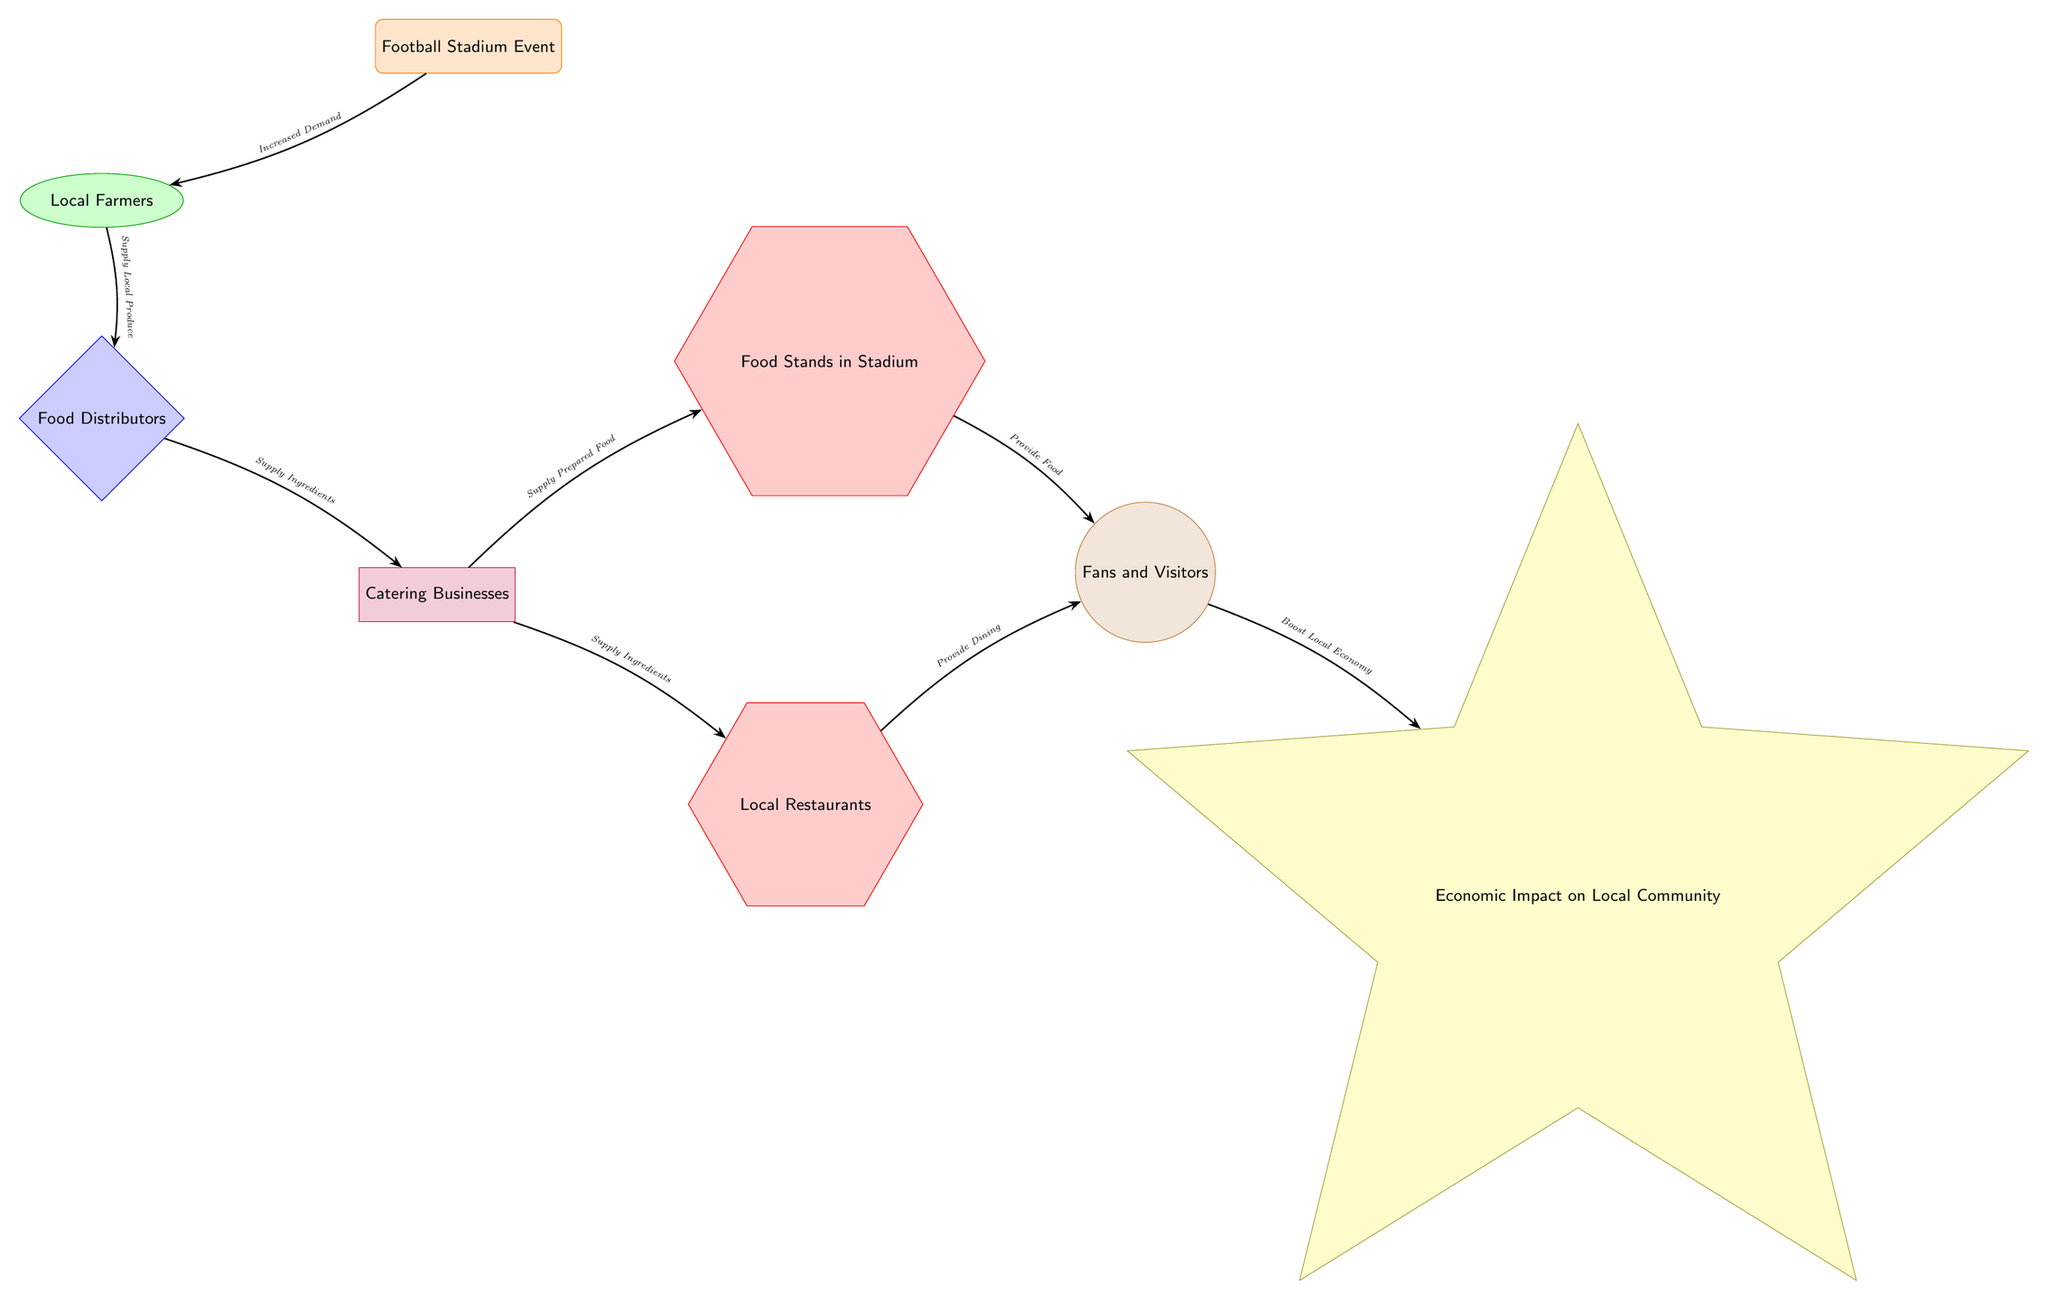What is the first node in the diagram? The first node in the diagram is the 'Football Stadium Event'. This is the starting point of the food chain presented.
Answer: Football Stadium Event How many nodes are connected to the 'Catering Businesses' node? The 'Catering Businesses' node is connected to two nodes: 'Food Stands in Stadium' and 'Local Restaurants'. Thus, there are two connections.
Answer: 2 What type of relationship exists between 'Local Farmers' and 'Food Distributors'? The relationship is one of supply, where 'Local Farmers' provide local produce to the 'Food Distributors'. This direct connection shows the flow of goods.
Answer: Supply Local Produce Who provides food to the fans? The 'Food Stands in Stadium' and 'Local Restaurants' both provide food to the 'Fans and Visitors'. Each contributes in their own capacity.
Answer: Food Stands in Stadium and Local Restaurants What is the economic impact of fans on the local community? The fans boost the local economy, which is represented as an economic outcome in the diagram's final node. This emphasizes the overall benefit of events on the local sector.
Answer: Boost Local Economy What flows from 'Catering Businesses' to 'Food Stands in Stadium'? From 'Catering Businesses' to 'Food Stands in Stadium', prepared food flows as a result of their supply relationship. This shows how food is offered to fans during events.
Answer: Supply Prepared Food What is the significance of 'Increased Demand' in the diagram? 'Increased Demand' signifies the effect of 'Football Stadium Event' on 'Local Farmers', indicating that events lead to a higher request for local produce.
Answer: Increased Demand Which node directly affects the 'Economic Impact on Local Community'? The node that directly affects the 'Economic Impact on Local Community' is 'Fans and Visitors' since they contribute to the local economy through their spending.
Answer: Fans and Visitors 